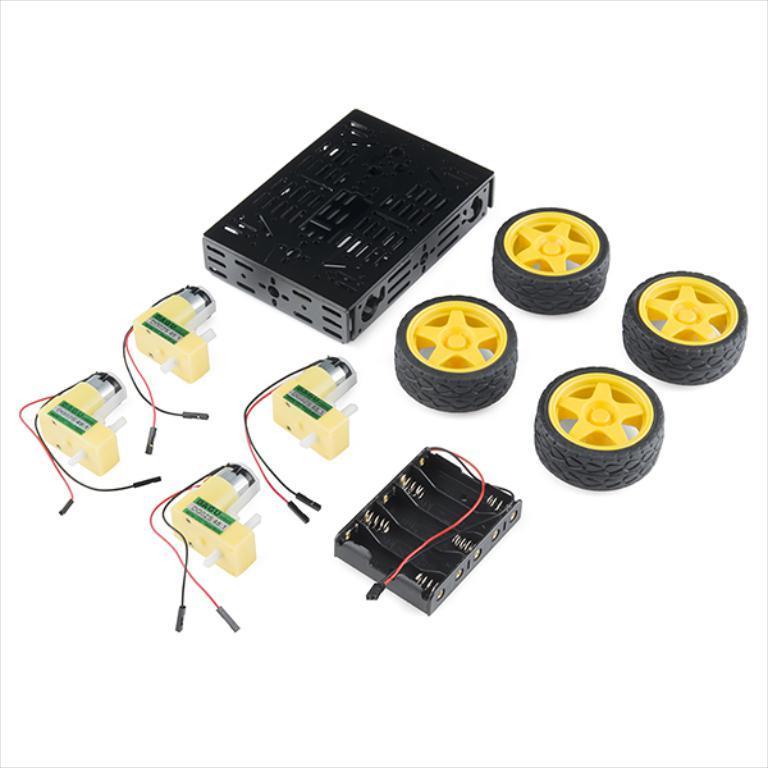How would you summarize this image in a sentence or two? In this image there are two mini boards, multi chassis and four wheels. 